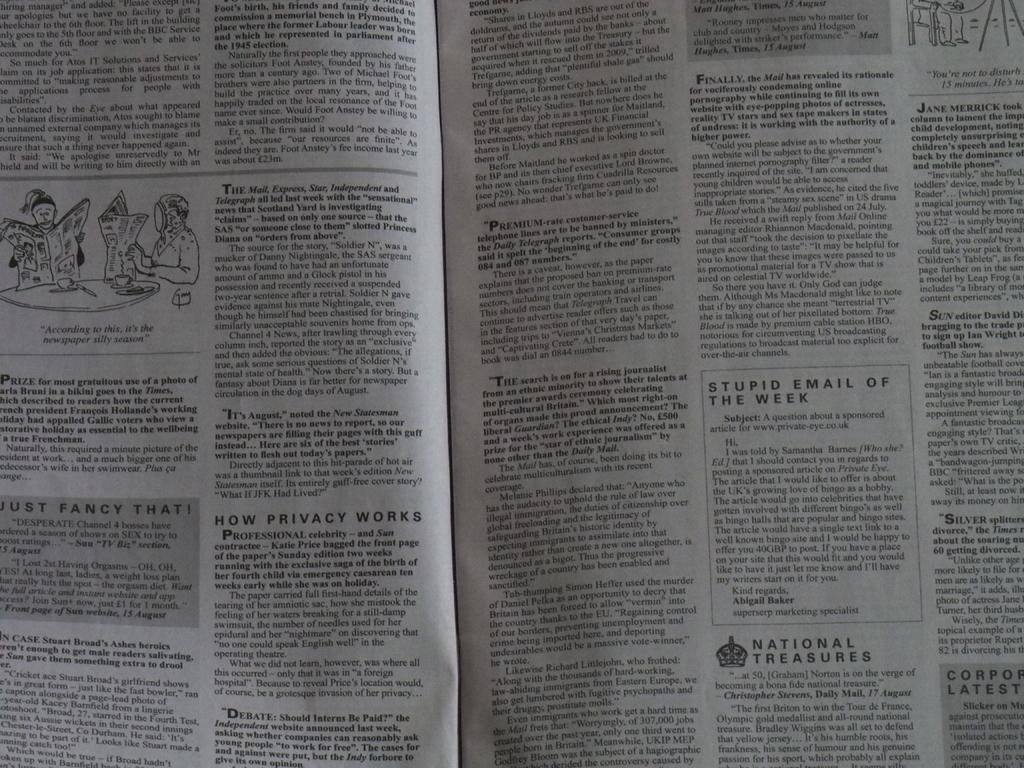<image>
Create a compact narrative representing the image presented. A publication includes several small stories and topics including "Stupid Emails of the Week". 